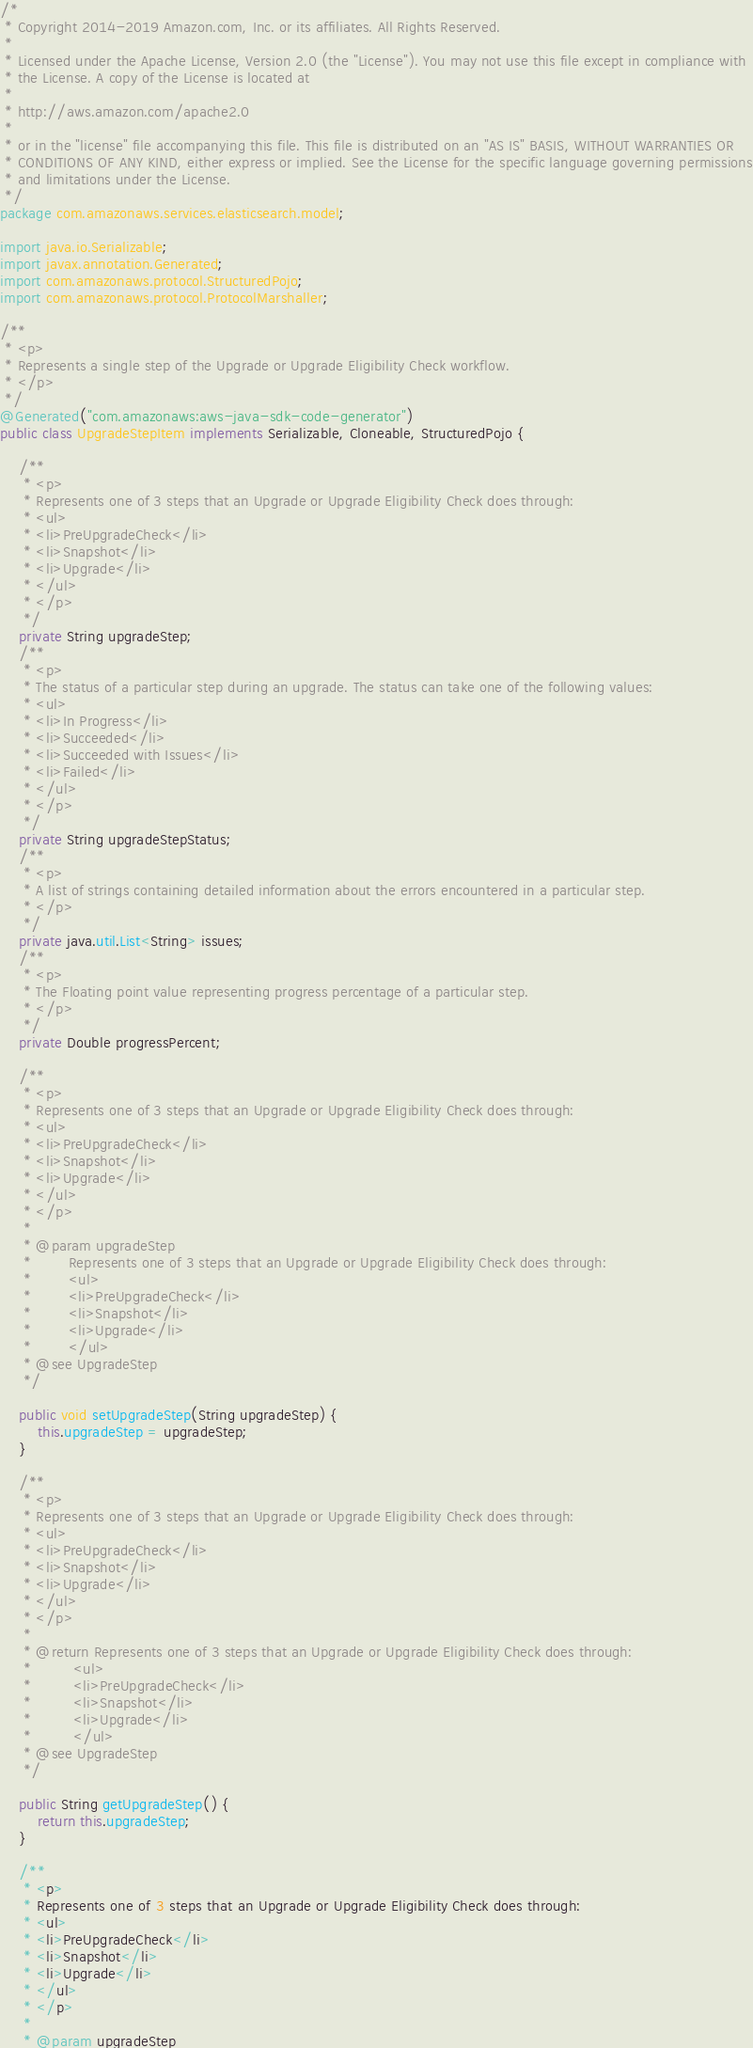<code> <loc_0><loc_0><loc_500><loc_500><_Java_>/*
 * Copyright 2014-2019 Amazon.com, Inc. or its affiliates. All Rights Reserved.
 * 
 * Licensed under the Apache License, Version 2.0 (the "License"). You may not use this file except in compliance with
 * the License. A copy of the License is located at
 * 
 * http://aws.amazon.com/apache2.0
 * 
 * or in the "license" file accompanying this file. This file is distributed on an "AS IS" BASIS, WITHOUT WARRANTIES OR
 * CONDITIONS OF ANY KIND, either express or implied. See the License for the specific language governing permissions
 * and limitations under the License.
 */
package com.amazonaws.services.elasticsearch.model;

import java.io.Serializable;
import javax.annotation.Generated;
import com.amazonaws.protocol.StructuredPojo;
import com.amazonaws.protocol.ProtocolMarshaller;

/**
 * <p>
 * Represents a single step of the Upgrade or Upgrade Eligibility Check workflow.
 * </p>
 */
@Generated("com.amazonaws:aws-java-sdk-code-generator")
public class UpgradeStepItem implements Serializable, Cloneable, StructuredPojo {

    /**
     * <p>
     * Represents one of 3 steps that an Upgrade or Upgrade Eligibility Check does through:
     * <ul>
     * <li>PreUpgradeCheck</li>
     * <li>Snapshot</li>
     * <li>Upgrade</li>
     * </ul>
     * </p>
     */
    private String upgradeStep;
    /**
     * <p>
     * The status of a particular step during an upgrade. The status can take one of the following values:
     * <ul>
     * <li>In Progress</li>
     * <li>Succeeded</li>
     * <li>Succeeded with Issues</li>
     * <li>Failed</li>
     * </ul>
     * </p>
     */
    private String upgradeStepStatus;
    /**
     * <p>
     * A list of strings containing detailed information about the errors encountered in a particular step.
     * </p>
     */
    private java.util.List<String> issues;
    /**
     * <p>
     * The Floating point value representing progress percentage of a particular step.
     * </p>
     */
    private Double progressPercent;

    /**
     * <p>
     * Represents one of 3 steps that an Upgrade or Upgrade Eligibility Check does through:
     * <ul>
     * <li>PreUpgradeCheck</li>
     * <li>Snapshot</li>
     * <li>Upgrade</li>
     * </ul>
     * </p>
     * 
     * @param upgradeStep
     *        Represents one of 3 steps that an Upgrade or Upgrade Eligibility Check does through:
     *        <ul>
     *        <li>PreUpgradeCheck</li>
     *        <li>Snapshot</li>
     *        <li>Upgrade</li>
     *        </ul>
     * @see UpgradeStep
     */

    public void setUpgradeStep(String upgradeStep) {
        this.upgradeStep = upgradeStep;
    }

    /**
     * <p>
     * Represents one of 3 steps that an Upgrade or Upgrade Eligibility Check does through:
     * <ul>
     * <li>PreUpgradeCheck</li>
     * <li>Snapshot</li>
     * <li>Upgrade</li>
     * </ul>
     * </p>
     * 
     * @return Represents one of 3 steps that an Upgrade or Upgrade Eligibility Check does through:
     *         <ul>
     *         <li>PreUpgradeCheck</li>
     *         <li>Snapshot</li>
     *         <li>Upgrade</li>
     *         </ul>
     * @see UpgradeStep
     */

    public String getUpgradeStep() {
        return this.upgradeStep;
    }

    /**
     * <p>
     * Represents one of 3 steps that an Upgrade or Upgrade Eligibility Check does through:
     * <ul>
     * <li>PreUpgradeCheck</li>
     * <li>Snapshot</li>
     * <li>Upgrade</li>
     * </ul>
     * </p>
     * 
     * @param upgradeStep</code> 